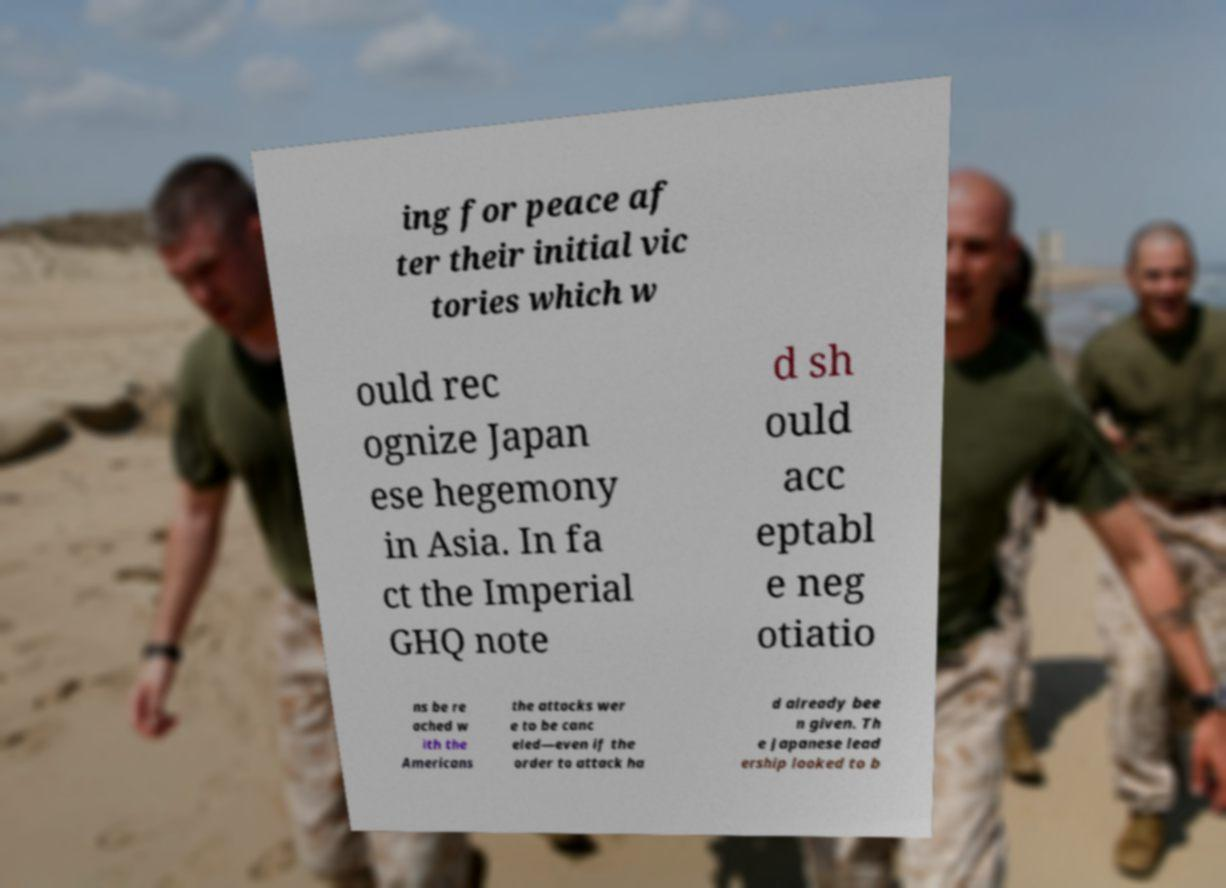Could you assist in decoding the text presented in this image and type it out clearly? ing for peace af ter their initial vic tories which w ould rec ognize Japan ese hegemony in Asia. In fa ct the Imperial GHQ note d sh ould acc eptabl e neg otiatio ns be re ached w ith the Americans the attacks wer e to be canc eled—even if the order to attack ha d already bee n given. Th e Japanese lead ership looked to b 